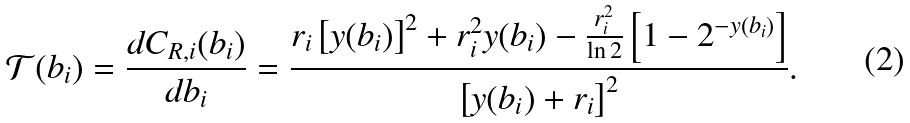<formula> <loc_0><loc_0><loc_500><loc_500>\mathcal { T } ( b _ { i } ) = \frac { d C _ { R , i } ( b _ { i } ) } { d b _ { i } } = \frac { r _ { i } \left [ y ( b _ { i } ) \right ] ^ { 2 } + r _ { i } ^ { 2 } y ( b _ { i } ) - \frac { r _ { i } ^ { 2 } } { \ln 2 } \left [ 1 - 2 ^ { - y ( b _ { i } ) } \right ] } { \left [ y ( b _ { i } ) + r _ { i } \right ] ^ { 2 } } .</formula> 